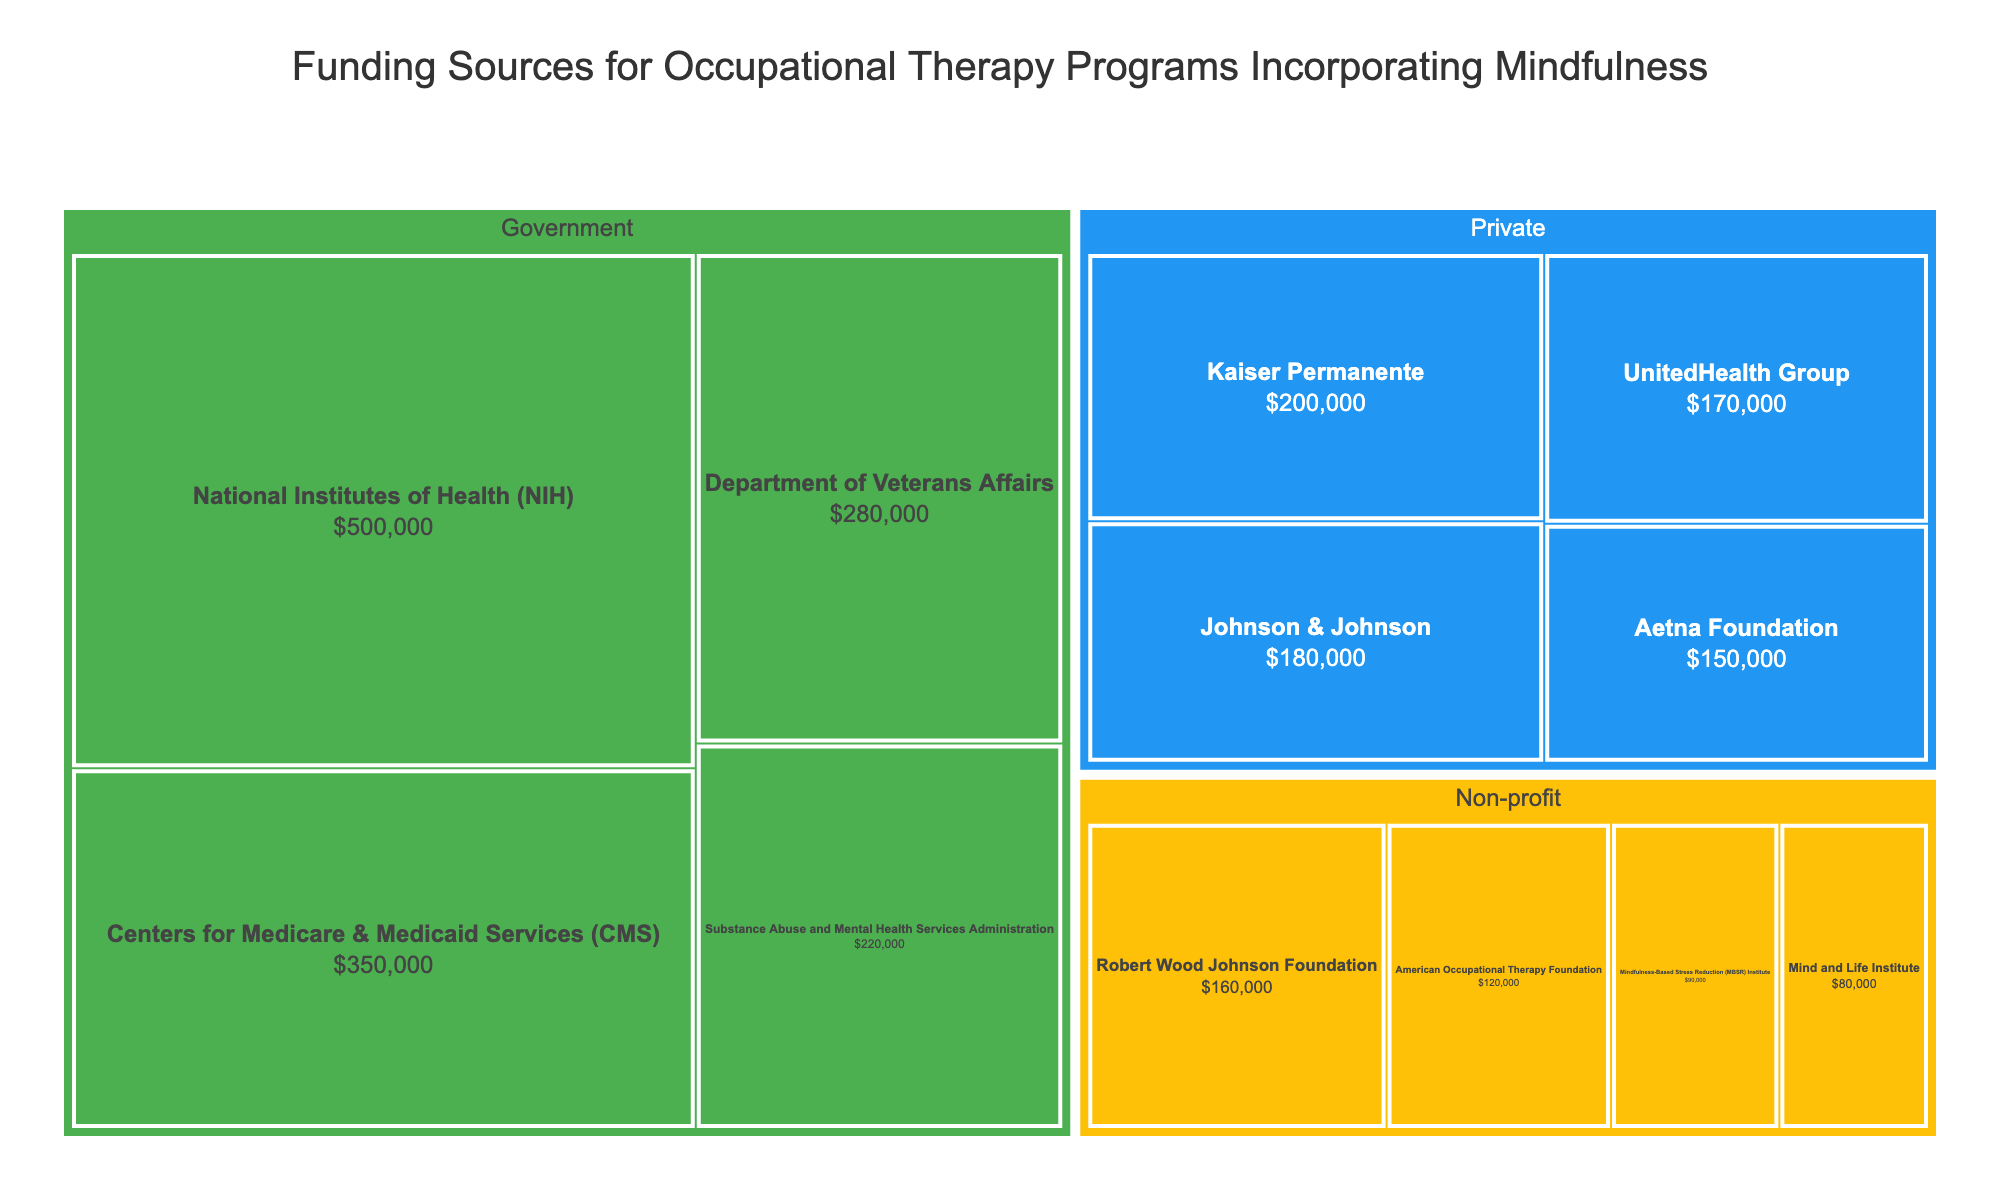What is the total funding amount from government sources? Add the amounts from all government sources: $500,000 (NIH) + $350,000 (CMS) + $280,000 (Department of Veterans Affairs) + $220,000 (Substance Abuse and Mental Health Services Administration) = $1,350,000
Answer: $1,350,000 Which category has the highest total funding? Compare the total funding amounts for each category: Government ($1,350,000), Private ($700,000: Kaiser Permanente $200,000 + Aetna Foundation $150,000 + Johnson & Johnson $180,000 + UnitedHealth Group $170,000), and Non-profit ($450,000: American Occupational Therapy Foundation $120,000 + MBSR Institute $90,000 + Robert Wood Johnson Foundation $160,000 + Mind and Life Institute $80,000). Government has the highest total funding
Answer: Government What is the smallest funding amount from any source? Identify the smallest value in the "Amount" column from all the sources listed: $80,000 (Mind and Life Institute)
Answer: $80,000 How does the funding from the Aetna Foundation compare to the funding from Kaiser Permanente? Compare the amounts: Kaiser Permanente ($200,000) is greater than Aetna Foundation ($150,000)
Answer: Kaiser Permanente What is the combined funding from private sources? Add the amounts from all private sources: $200,000 (Kaiser Permanente) + $150,000 (Aetna Foundation) + $180,000 (Johnson & Johnson) + $170,000 (UnitedHealth Group) = $700,000
Answer: $700,000 Which non-profit source has the highest funding amount? Compare the funding amounts of non-profit sources: American Occupational Therapy Foundation ($120,000), MBSR Institute ($90,000), Robert Wood Johnson Foundation ($160,000), Mind and Life Institute ($80,000). The Robert Wood Johnson Foundation has the highest funding amount
Answer: Robert Wood Johnson Foundation What percentage of the total funding is provided by non-profit organizations? Calculate the total funding: $1,350,000 (Government) + $700,000 (Private) + $450,000 (Non-profit) = $2,500,000. Calculate the percentage: ($450,000 / $2,500,000) * 100 = 18%
Answer: 18% Which funding categories contribute more than $500,000? Government ($1,350,000) and Private ($700,000) contribute more than $500,000. Non-profit only contributes $450,000
Answer: Government, Private 